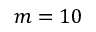Convert formula to latex. <formula><loc_0><loc_0><loc_500><loc_500>m = 1 0</formula> 